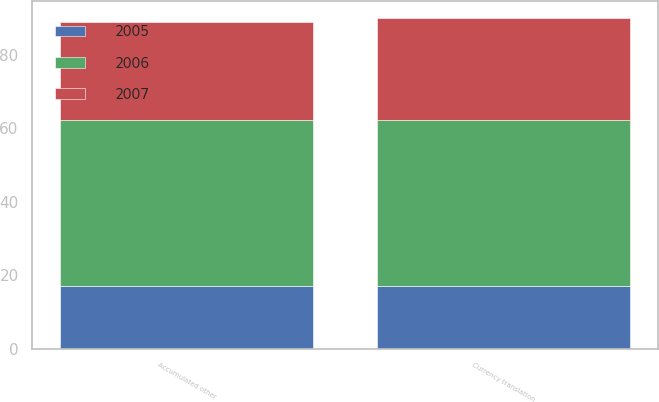Convert chart to OTSL. <chart><loc_0><loc_0><loc_500><loc_500><stacked_bar_chart><ecel><fcel>Currency translation<fcel>Accumulated other<nl><fcel>2007<fcel>27.7<fcel>26.6<nl><fcel>2006<fcel>45.2<fcel>45.2<nl><fcel>2005<fcel>17.2<fcel>17.2<nl></chart> 